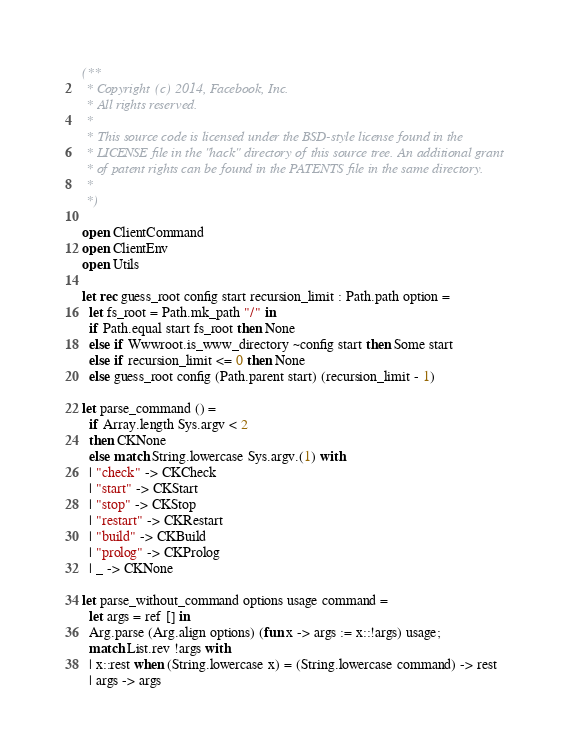Convert code to text. <code><loc_0><loc_0><loc_500><loc_500><_OCaml_>(**
 * Copyright (c) 2014, Facebook, Inc.
 * All rights reserved.
 *
 * This source code is licensed under the BSD-style license found in the
 * LICENSE file in the "hack" directory of this source tree. An additional grant
 * of patent rights can be found in the PATENTS file in the same directory.
 *
 *)

open ClientCommand
open ClientEnv
open Utils

let rec guess_root config start recursion_limit : Path.path option =
  let fs_root = Path.mk_path "/" in
  if Path.equal start fs_root then None
  else if Wwwroot.is_www_directory ~config start then Some start
  else if recursion_limit <= 0 then None
  else guess_root config (Path.parent start) (recursion_limit - 1)

let parse_command () =
  if Array.length Sys.argv < 2
  then CKNone
  else match String.lowercase Sys.argv.(1) with
  | "check" -> CKCheck
  | "start" -> CKStart
  | "stop" -> CKStop
  | "restart" -> CKRestart
  | "build" -> CKBuild
  | "prolog" -> CKProlog
  | _ -> CKNone

let parse_without_command options usage command =
  let args = ref [] in
  Arg.parse (Arg.align options) (fun x -> args := x::!args) usage;
  match List.rev !args with
  | x::rest when (String.lowercase x) = (String.lowercase command) -> rest
  | args -> args
</code> 